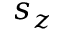<formula> <loc_0><loc_0><loc_500><loc_500>s _ { z }</formula> 